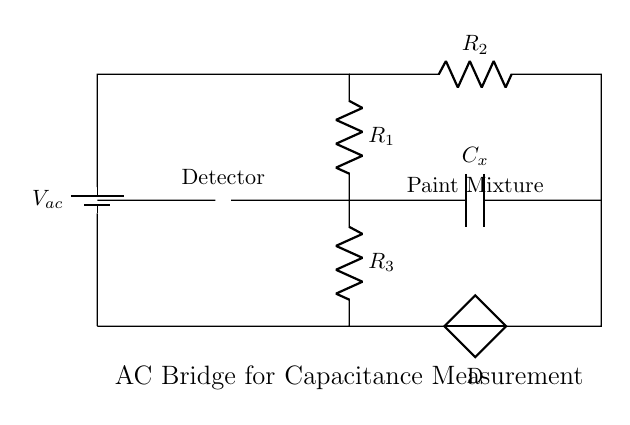What is the key purpose of this circuit? The circuit is an AC Bridge for measuring capacitance, which indicates it is designed to measure the capacitance of the paint mixtures by balancing the bridge.
Answer: Measuring capacitance What component represents the paint mixture? The component labeled as "Paint Mixture" is the capacitor with the label Cx, which represents the unknown capacitance being measured.
Answer: Cx What are the resistance values in this circuit? The circuit contains three resistors labeled R1, R2, and R3, but specific numerical values for these resistors are not provided in the diagram; only their labels are visible.
Answer: R1, R2, R3 How is the detector connected in the circuit? The detector is connected between the points where the branches intersect; it measures the difference in potential between them, positioned between the two branches connecting to R1 and R2.
Answer: Between R1 and R2 What type of current does this circuit use? The circuit uses alternating current, indicated by the voltage source labeled as Vac, which is a common designation for AC sources in circuits.
Answer: Alternating current What does the presence of the battery indicate in the circuit? The battery provides a test voltage, essential for ensuring that the circuit operates and measures the capacitance of the paint mixtures effectively.
Answer: Test voltage 